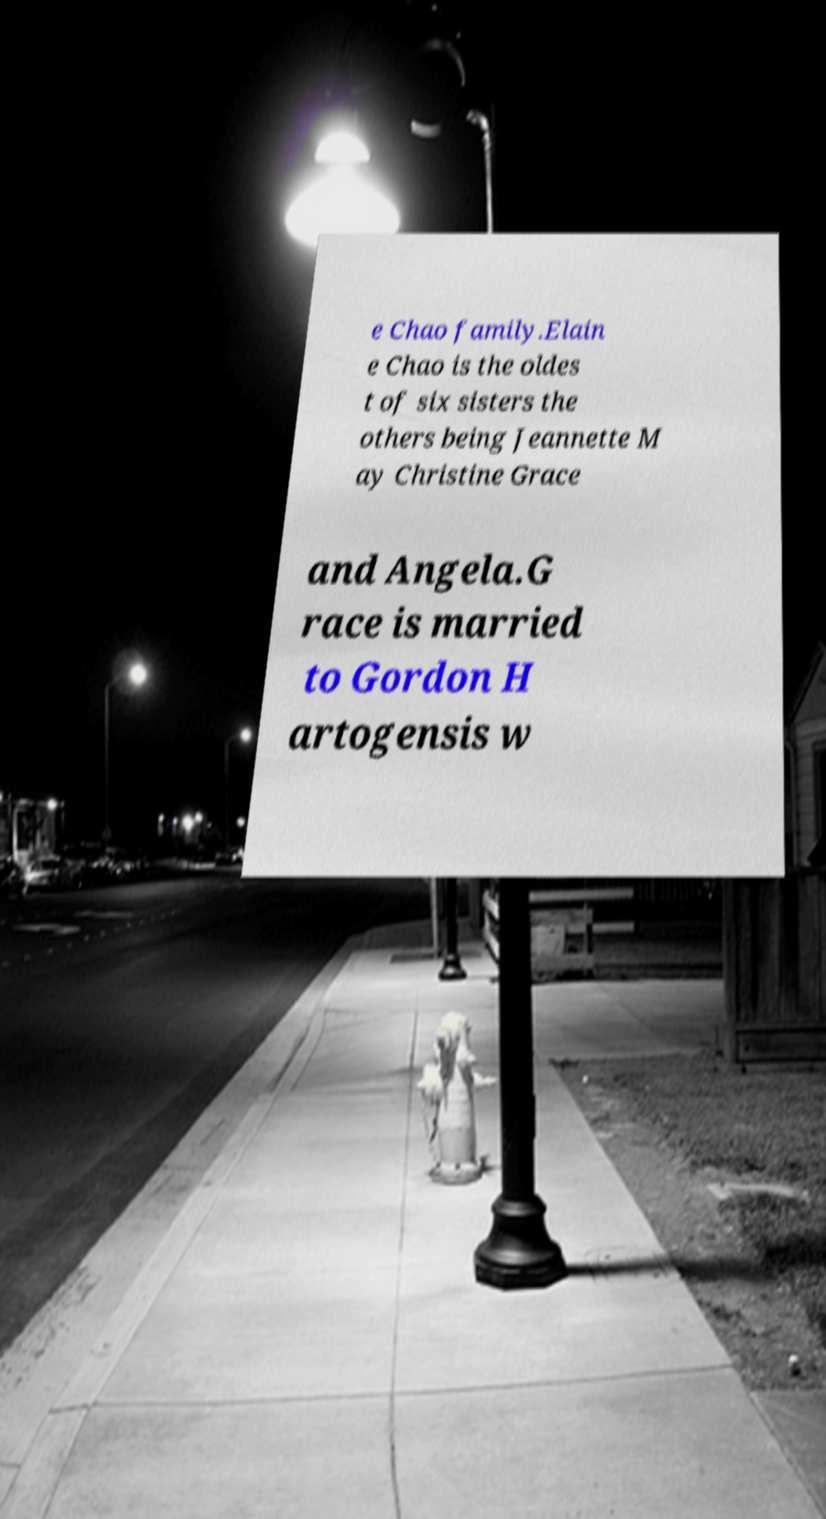There's text embedded in this image that I need extracted. Can you transcribe it verbatim? e Chao family.Elain e Chao is the oldes t of six sisters the others being Jeannette M ay Christine Grace and Angela.G race is married to Gordon H artogensis w 